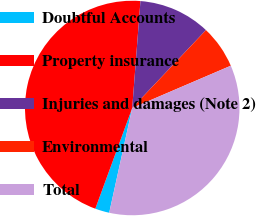Convert chart to OTSL. <chart><loc_0><loc_0><loc_500><loc_500><pie_chart><fcel>Doubtful Accounts<fcel>Property insurance<fcel>Injuries and damages (Note 2)<fcel>Environmental<fcel>Total<nl><fcel>2.15%<fcel>45.63%<fcel>10.84%<fcel>6.49%<fcel>34.89%<nl></chart> 